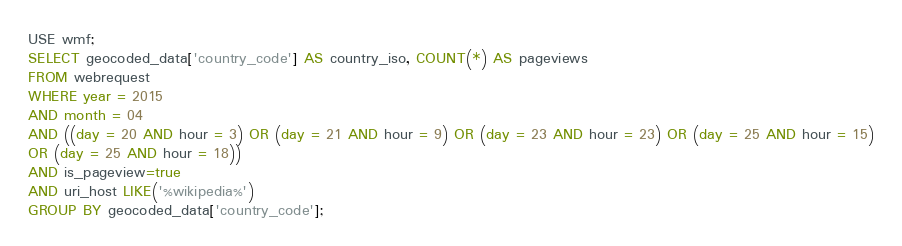<code> <loc_0><loc_0><loc_500><loc_500><_SQL_>USE wmf;
SELECT geocoded_data['country_code'] AS country_iso, COUNT(*) AS pageviews
FROM webrequest
WHERE year = 2015
AND month = 04
AND ((day = 20 AND hour = 3) OR (day = 21 AND hour = 9) OR (day = 23 AND hour = 23) OR (day = 25 AND hour = 15)
OR (day = 25 AND hour = 18))
AND is_pageview=true
AND uri_host LIKE('%wikipedia%')
GROUP BY geocoded_data['country_code'];</code> 